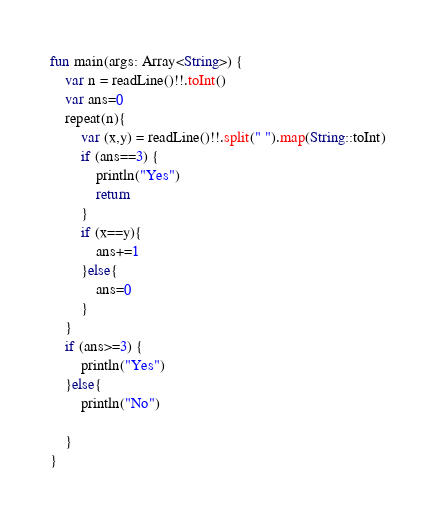Convert code to text. <code><loc_0><loc_0><loc_500><loc_500><_Kotlin_>fun main(args: Array<String>) {
    var n = readLine()!!.toInt()
    var ans=0
    repeat(n){
        var (x,y) = readLine()!!.split(" ").map(String::toInt)
        if (ans==3) {
            println("Yes")
            return
        }
        if (x==y){
            ans+=1
        }else{
            ans=0
        }
    }
    if (ans>=3) {
        println("Yes")
    }else{
        println("No")

    }
}</code> 